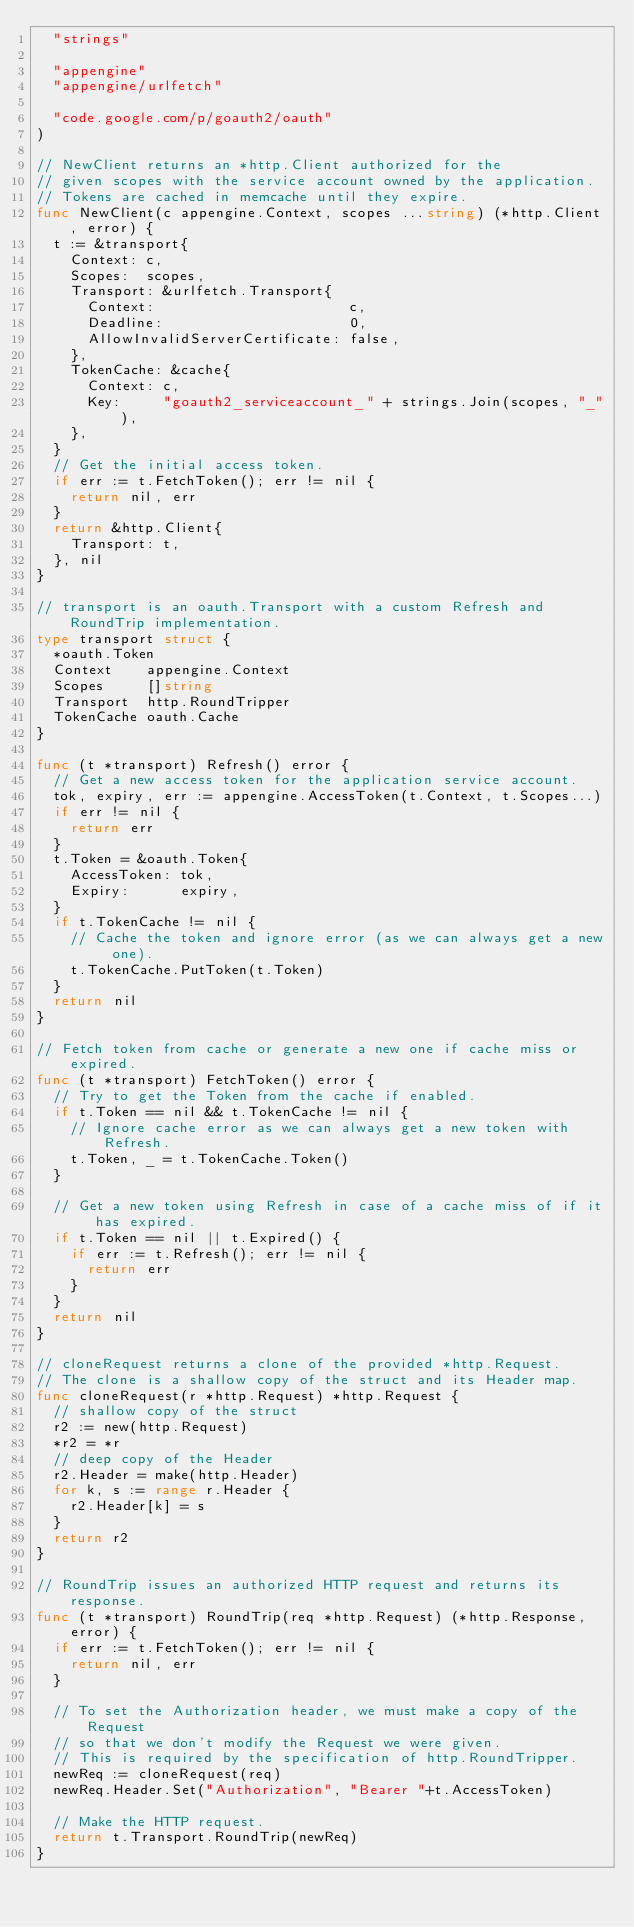<code> <loc_0><loc_0><loc_500><loc_500><_Go_>	"strings"

	"appengine"
	"appengine/urlfetch"

	"code.google.com/p/goauth2/oauth"
)

// NewClient returns an *http.Client authorized for the
// given scopes with the service account owned by the application.
// Tokens are cached in memcache until they expire.
func NewClient(c appengine.Context, scopes ...string) (*http.Client, error) {
	t := &transport{
		Context: c,
		Scopes:  scopes,
		Transport: &urlfetch.Transport{
			Context:                       c,
			Deadline:                      0,
			AllowInvalidServerCertificate: false,
		},
		TokenCache: &cache{
			Context: c,
			Key:     "goauth2_serviceaccount_" + strings.Join(scopes, "_"),
		},
	}
	// Get the initial access token.
	if err := t.FetchToken(); err != nil {
		return nil, err
	}
	return &http.Client{
		Transport: t,
	}, nil
}

// transport is an oauth.Transport with a custom Refresh and RoundTrip implementation.
type transport struct {
	*oauth.Token
	Context    appengine.Context
	Scopes     []string
	Transport  http.RoundTripper
	TokenCache oauth.Cache
}

func (t *transport) Refresh() error {
	// Get a new access token for the application service account.
	tok, expiry, err := appengine.AccessToken(t.Context, t.Scopes...)
	if err != nil {
		return err
	}
	t.Token = &oauth.Token{
		AccessToken: tok,
		Expiry:      expiry,
	}
	if t.TokenCache != nil {
		// Cache the token and ignore error (as we can always get a new one).
		t.TokenCache.PutToken(t.Token)
	}
	return nil
}

// Fetch token from cache or generate a new one if cache miss or expired.
func (t *transport) FetchToken() error {
	// Try to get the Token from the cache if enabled.
	if t.Token == nil && t.TokenCache != nil {
		// Ignore cache error as we can always get a new token with Refresh.
		t.Token, _ = t.TokenCache.Token()
	}

	// Get a new token using Refresh in case of a cache miss of if it has expired.
	if t.Token == nil || t.Expired() {
		if err := t.Refresh(); err != nil {
			return err
		}
	}
	return nil
}

// cloneRequest returns a clone of the provided *http.Request.
// The clone is a shallow copy of the struct and its Header map.
func cloneRequest(r *http.Request) *http.Request {
	// shallow copy of the struct
	r2 := new(http.Request)
	*r2 = *r
	// deep copy of the Header
	r2.Header = make(http.Header)
	for k, s := range r.Header {
		r2.Header[k] = s
	}
	return r2
}

// RoundTrip issues an authorized HTTP request and returns its response.
func (t *transport) RoundTrip(req *http.Request) (*http.Response, error) {
	if err := t.FetchToken(); err != nil {
		return nil, err
	}

	// To set the Authorization header, we must make a copy of the Request
	// so that we don't modify the Request we were given.
	// This is required by the specification of http.RoundTripper.
	newReq := cloneRequest(req)
	newReq.Header.Set("Authorization", "Bearer "+t.AccessToken)

	// Make the HTTP request.
	return t.Transport.RoundTrip(newReq)
}
</code> 